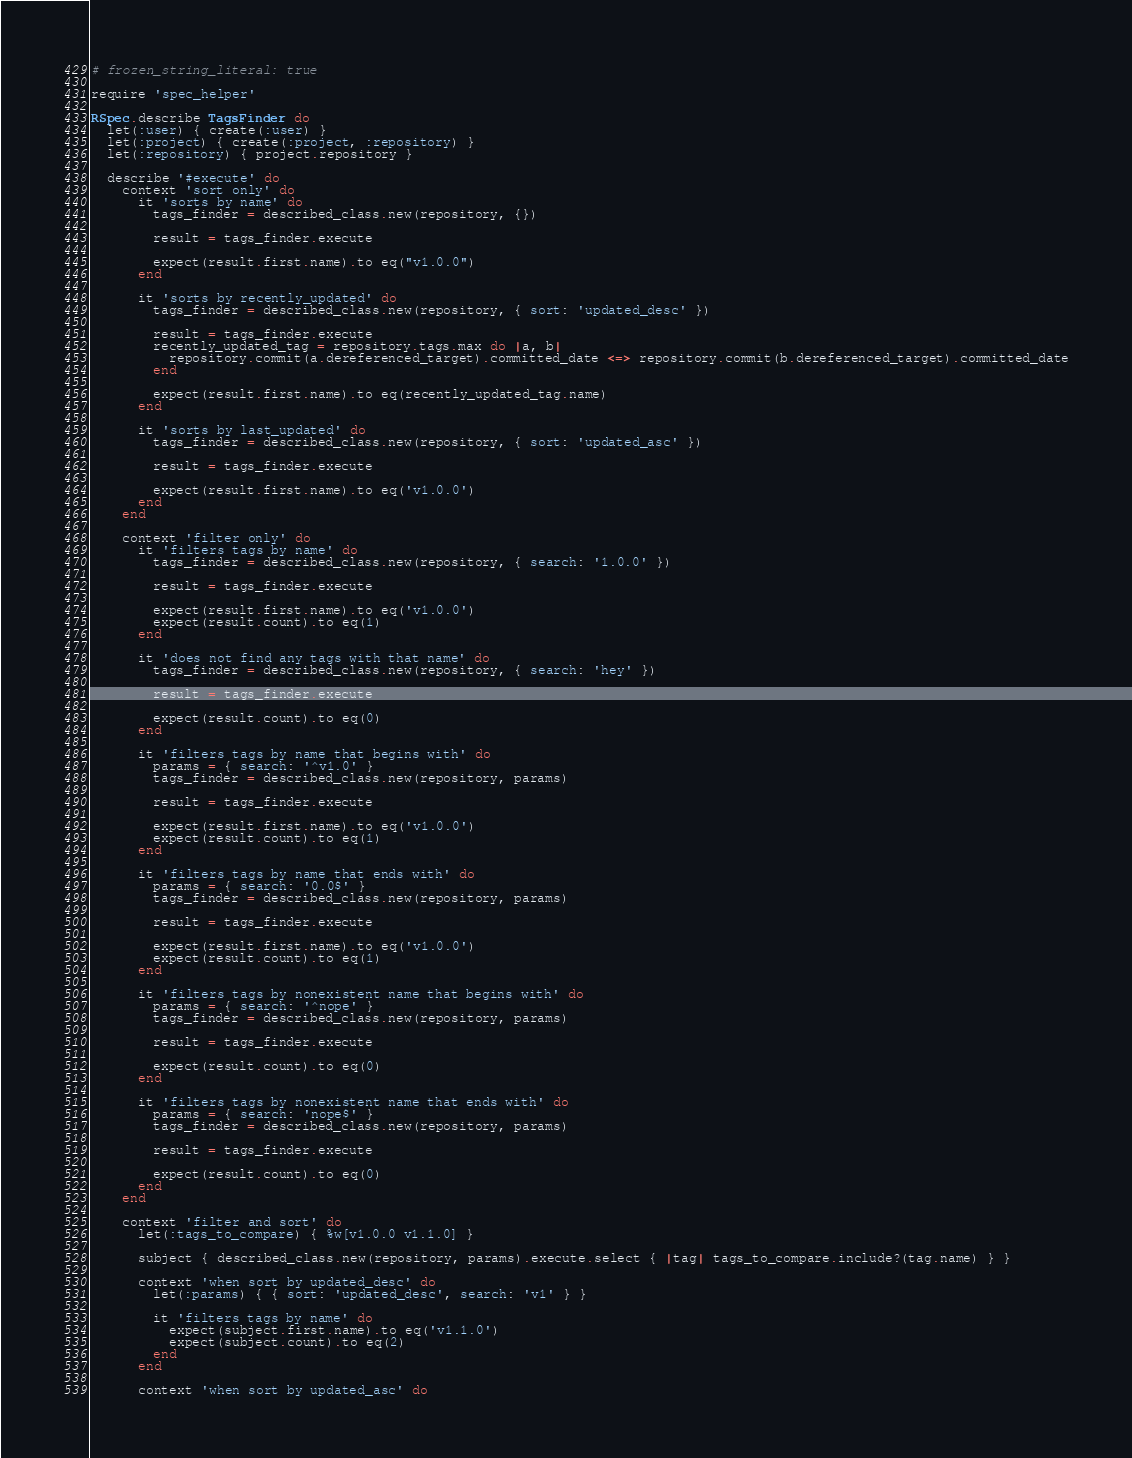Convert code to text. <code><loc_0><loc_0><loc_500><loc_500><_Ruby_># frozen_string_literal: true

require 'spec_helper'

RSpec.describe TagsFinder do
  let(:user) { create(:user) }
  let(:project) { create(:project, :repository) }
  let(:repository) { project.repository }

  describe '#execute' do
    context 'sort only' do
      it 'sorts by name' do
        tags_finder = described_class.new(repository, {})

        result = tags_finder.execute

        expect(result.first.name).to eq("v1.0.0")
      end

      it 'sorts by recently_updated' do
        tags_finder = described_class.new(repository, { sort: 'updated_desc' })

        result = tags_finder.execute
        recently_updated_tag = repository.tags.max do |a, b|
          repository.commit(a.dereferenced_target).committed_date <=> repository.commit(b.dereferenced_target).committed_date
        end

        expect(result.first.name).to eq(recently_updated_tag.name)
      end

      it 'sorts by last_updated' do
        tags_finder = described_class.new(repository, { sort: 'updated_asc' })

        result = tags_finder.execute

        expect(result.first.name).to eq('v1.0.0')
      end
    end

    context 'filter only' do
      it 'filters tags by name' do
        tags_finder = described_class.new(repository, { search: '1.0.0' })

        result = tags_finder.execute

        expect(result.first.name).to eq('v1.0.0')
        expect(result.count).to eq(1)
      end

      it 'does not find any tags with that name' do
        tags_finder = described_class.new(repository, { search: 'hey' })

        result = tags_finder.execute

        expect(result.count).to eq(0)
      end

      it 'filters tags by name that begins with' do
        params = { search: '^v1.0' }
        tags_finder = described_class.new(repository, params)

        result = tags_finder.execute

        expect(result.first.name).to eq('v1.0.0')
        expect(result.count).to eq(1)
      end

      it 'filters tags by name that ends with' do
        params = { search: '0.0$' }
        tags_finder = described_class.new(repository, params)

        result = tags_finder.execute

        expect(result.first.name).to eq('v1.0.0')
        expect(result.count).to eq(1)
      end

      it 'filters tags by nonexistent name that begins with' do
        params = { search: '^nope' }
        tags_finder = described_class.new(repository, params)

        result = tags_finder.execute

        expect(result.count).to eq(0)
      end

      it 'filters tags by nonexistent name that ends with' do
        params = { search: 'nope$' }
        tags_finder = described_class.new(repository, params)

        result = tags_finder.execute

        expect(result.count).to eq(0)
      end
    end

    context 'filter and sort' do
      let(:tags_to_compare) { %w[v1.0.0 v1.1.0] }

      subject { described_class.new(repository, params).execute.select { |tag| tags_to_compare.include?(tag.name) } }

      context 'when sort by updated_desc' do
        let(:params) { { sort: 'updated_desc', search: 'v1' } }

        it 'filters tags by name' do
          expect(subject.first.name).to eq('v1.1.0')
          expect(subject.count).to eq(2)
        end
      end

      context 'when sort by updated_asc' do</code> 